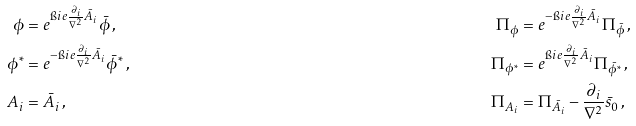Convert formula to latex. <formula><loc_0><loc_0><loc_500><loc_500>\phi & = e ^ { \i i e \frac { \partial _ { i } } { \nabla ^ { 2 } } { \bar { A } } _ { i } } { \bar { \phi } } \, , & \Pi _ { \phi } & = e ^ { - \i i e \frac { \partial _ { i } } { \nabla ^ { 2 } } { \bar { A } } _ { i } } \Pi _ { \bar { \phi } } \, , \\ \phi ^ { * } & = e ^ { - \i i e \frac { \partial _ { i } } { \nabla ^ { 2 } } { \bar { A } } _ { i } } { \bar { \phi } } ^ { * } \, , & \Pi _ { \phi ^ { * } } & = e ^ { \i i e \frac { \partial _ { i } } { \nabla ^ { 2 } } { \bar { A } } _ { i } } \Pi _ { { \bar { \phi } } ^ { * } } \, , \\ A _ { i } & = { \bar { A } } _ { i } \, , & \Pi _ { A _ { i } } & = \Pi _ { { \bar { A } } _ { i } } - \frac { \partial _ { i } } { \nabla ^ { 2 } } { \bar { s } } _ { 0 } \, ,</formula> 